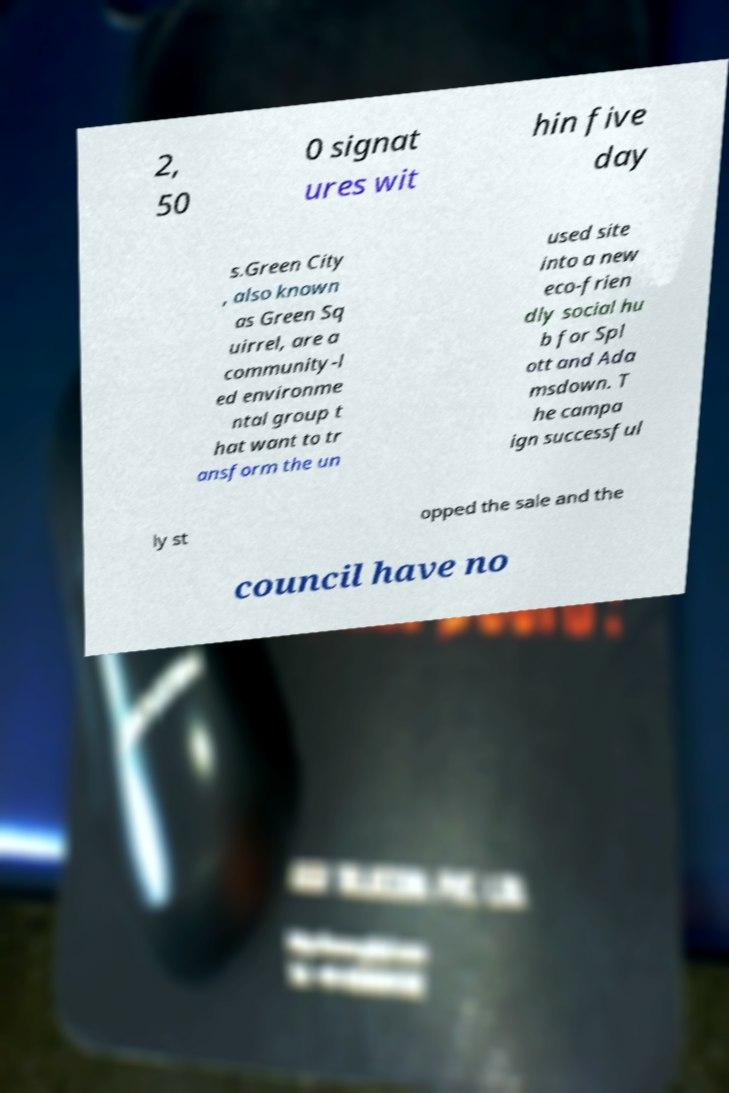I need the written content from this picture converted into text. Can you do that? 2, 50 0 signat ures wit hin five day s.Green City , also known as Green Sq uirrel, are a community-l ed environme ntal group t hat want to tr ansform the un used site into a new eco-frien dly social hu b for Spl ott and Ada msdown. T he campa ign successful ly st opped the sale and the council have no 